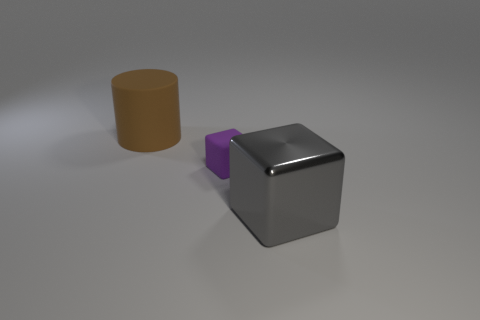Add 3 tiny purple things. How many objects exist? 6 Subtract all blocks. How many objects are left? 1 Subtract all yellow matte objects. Subtract all tiny blocks. How many objects are left? 2 Add 2 big matte things. How many big matte things are left? 3 Add 1 small brown cubes. How many small brown cubes exist? 1 Subtract 0 red cylinders. How many objects are left? 3 